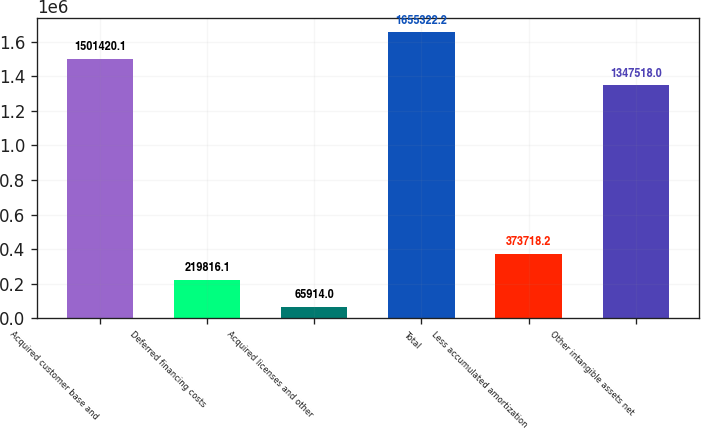Convert chart to OTSL. <chart><loc_0><loc_0><loc_500><loc_500><bar_chart><fcel>Acquired customer base and<fcel>Deferred financing costs<fcel>Acquired licenses and other<fcel>Total<fcel>Less accumulated amortization<fcel>Other intangible assets net<nl><fcel>1.50142e+06<fcel>219816<fcel>65914<fcel>1.65532e+06<fcel>373718<fcel>1.34752e+06<nl></chart> 